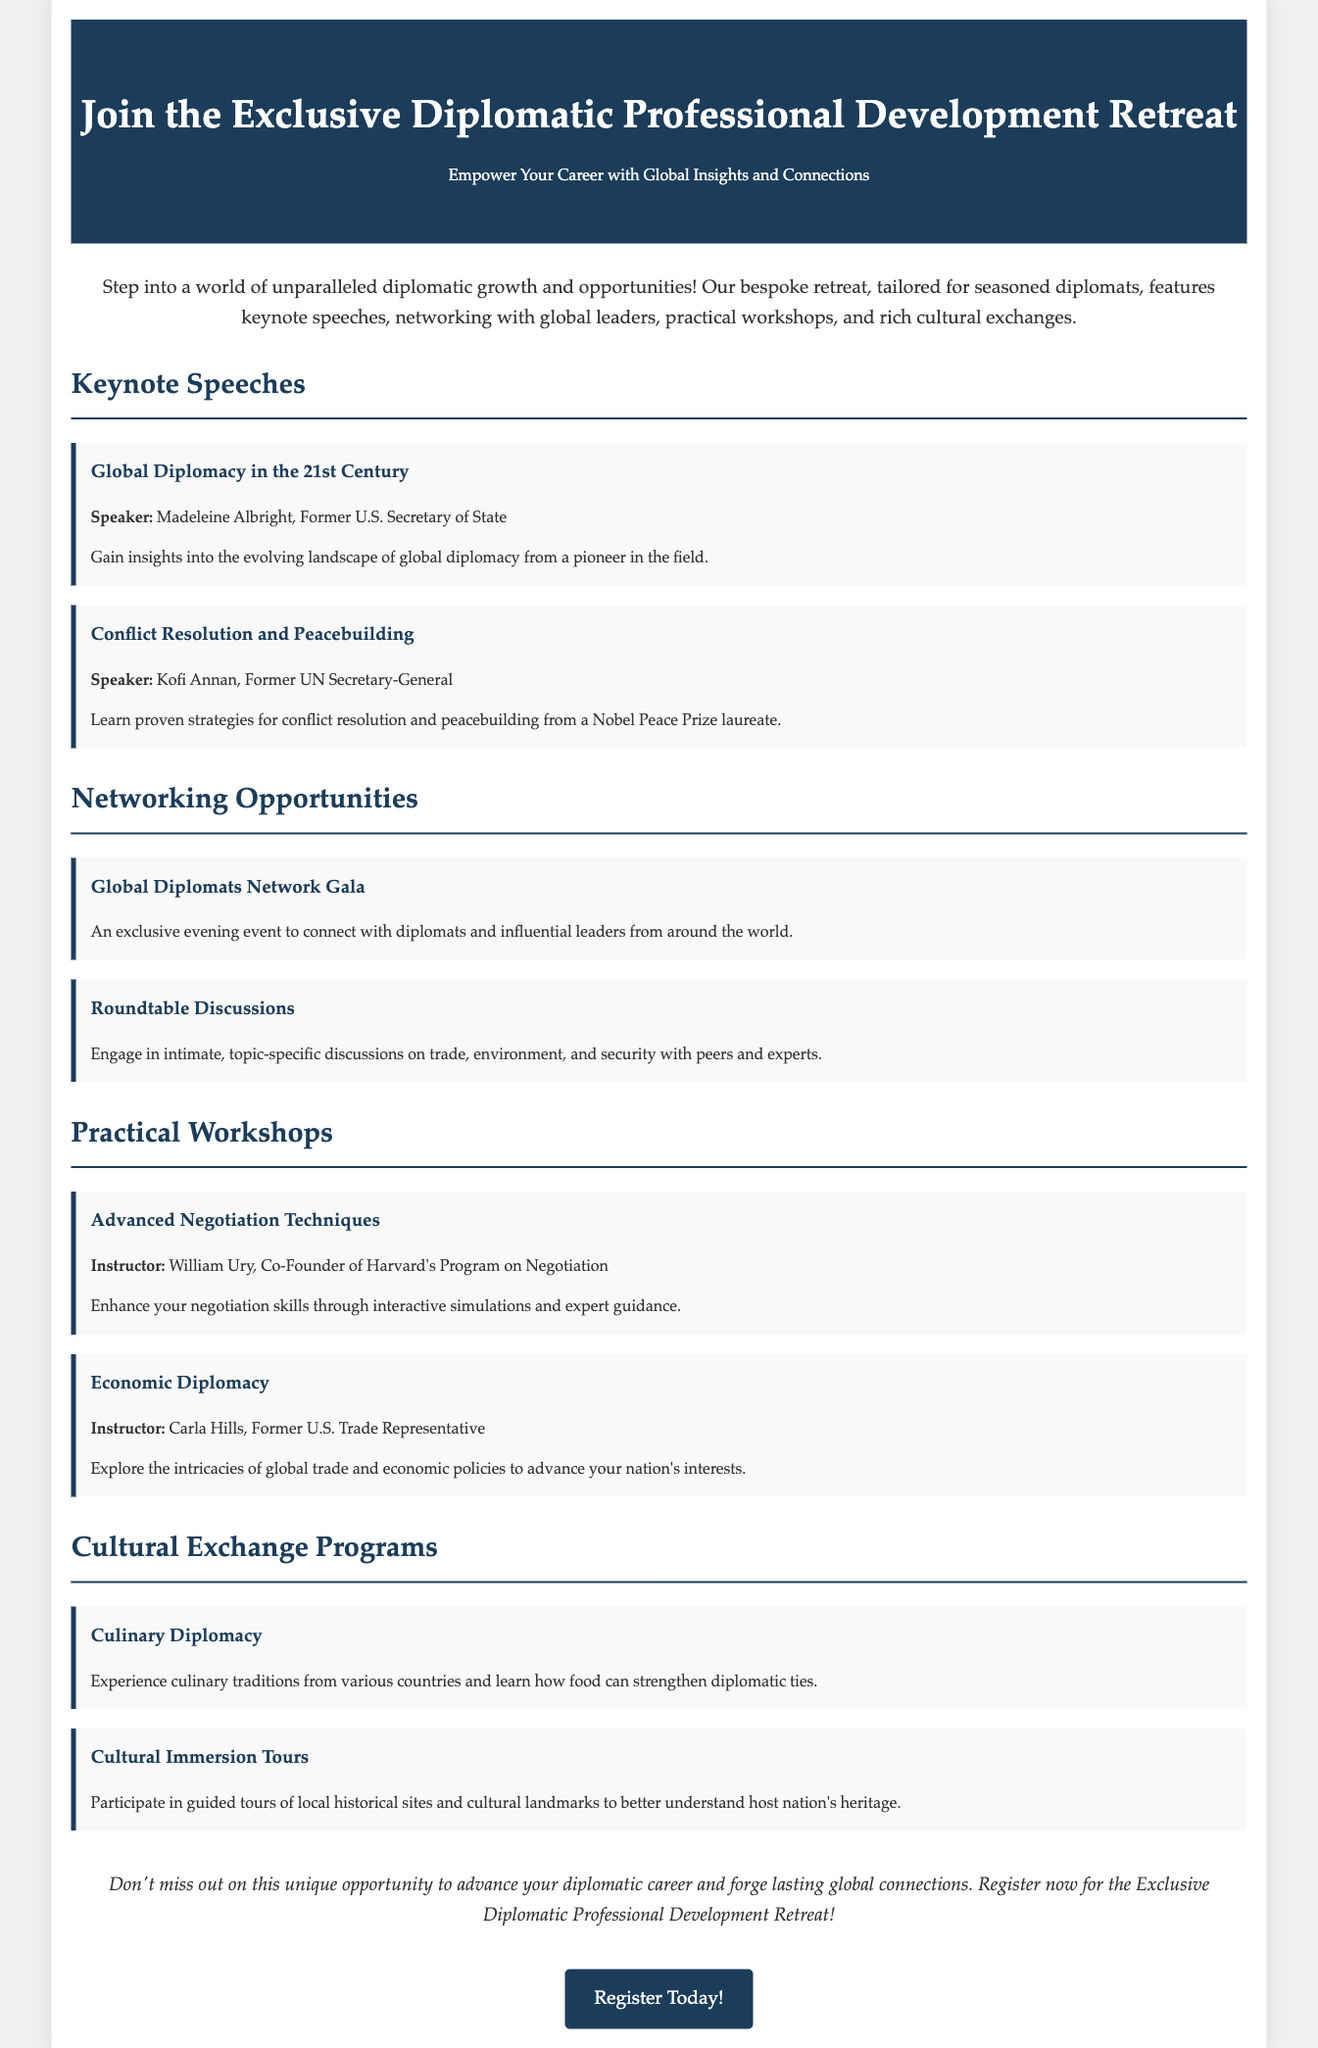What is the title of the retreat? The title of the retreat is prominently mentioned at the top of the document.
Answer: Exclusive Diplomatic Professional Development Retreat Who is the keynote speaker for "Global Diplomacy in the 21st Century"? The document lists the speaker for this keynote as a prominent figure in diplomacy.
Answer: Madeleine Albright What type of event is the "Global Diplomats Network Gala"? This event is described as an exclusive evening event, highlighting its networking purpose for diplomats.
Answer: Networking opportunity Who instructs the workshop on "Advanced Negotiation Techniques"? The document provides information about the instructor of this particular workshop.
Answer: William Ury What is the focus of the "Culinary Diplomacy" program? The description of this program reveals its aim in enhancing diplomatic relations through a specific cultural element.
Answer: Strengthen diplomatic ties How many workshops are mentioned in total? Total count of workshops specified in the document can be determined by adding those listed under practical workshops.
Answer: Two 